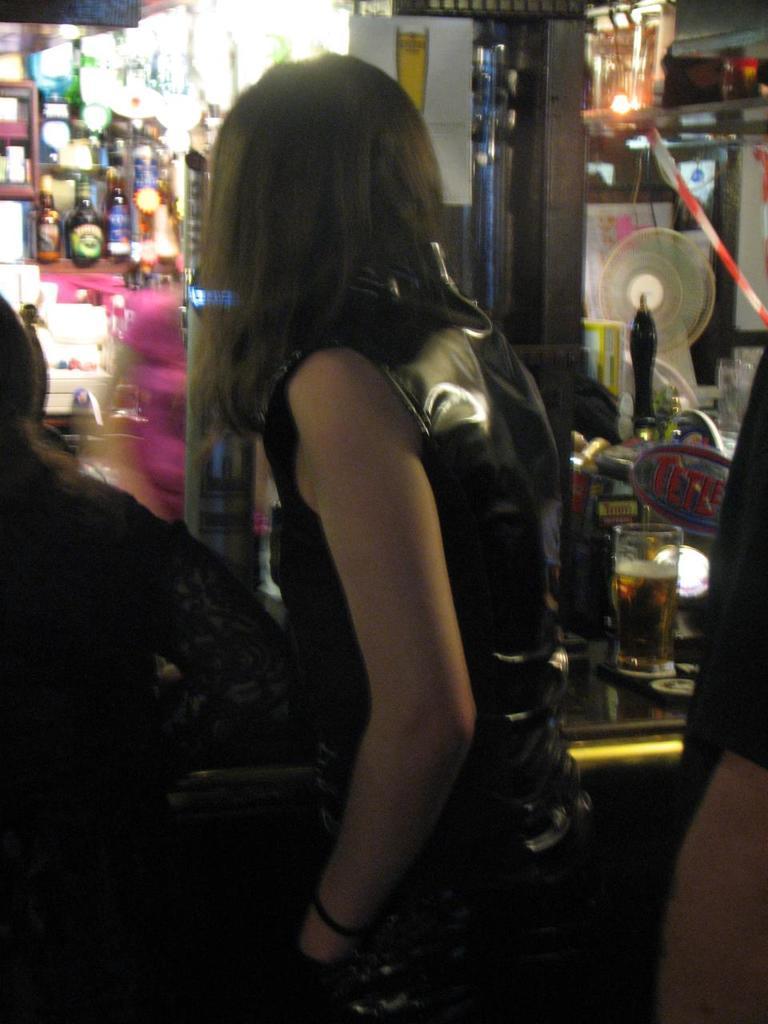In one or two sentences, can you explain what this image depicts? In this picture we can see three people and a woman standing, glass with drink in it, bottles in racks, lights, fan, poster and some objects. 